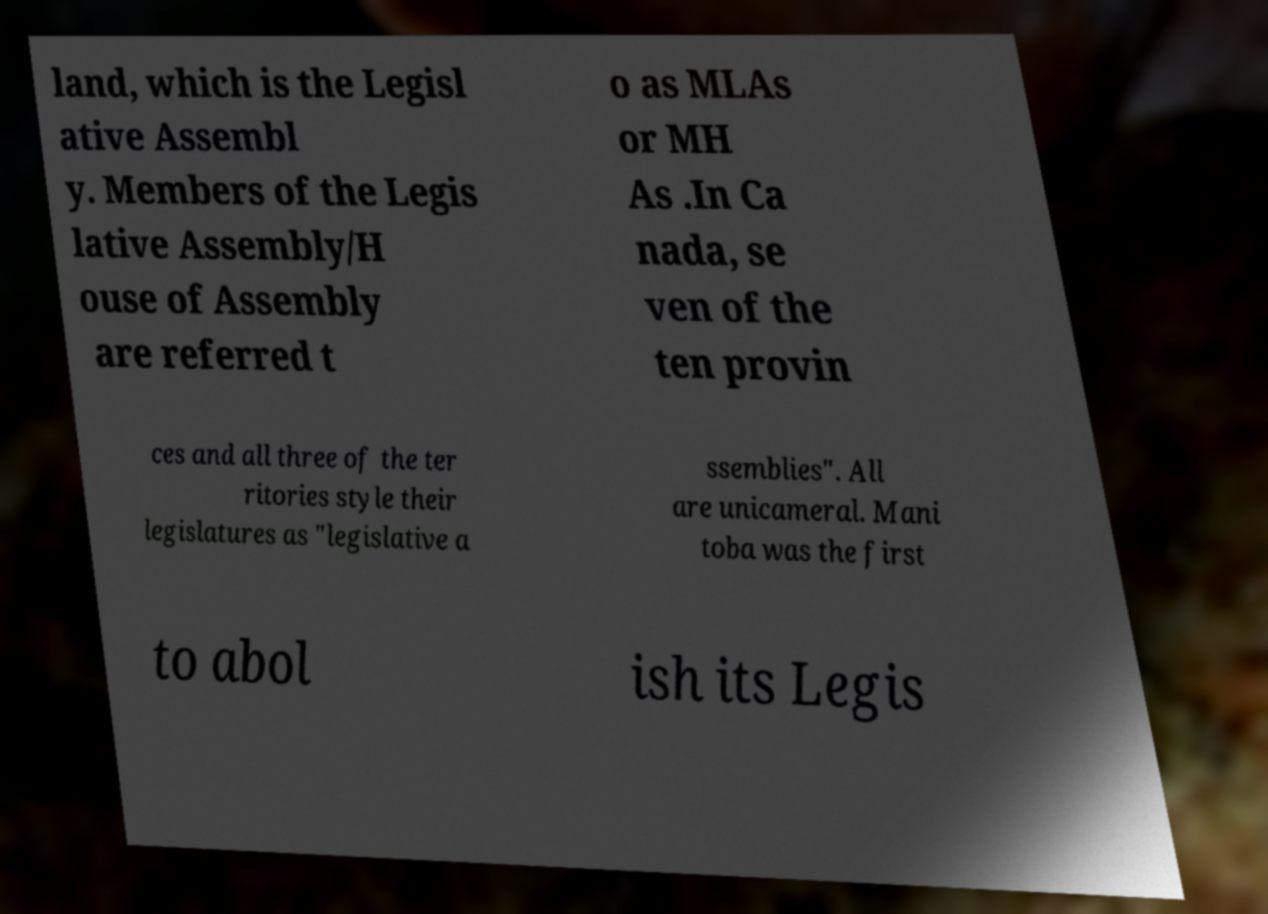There's text embedded in this image that I need extracted. Can you transcribe it verbatim? land, which is the Legisl ative Assembl y. Members of the Legis lative Assembly/H ouse of Assembly are referred t o as MLAs or MH As .In Ca nada, se ven of the ten provin ces and all three of the ter ritories style their legislatures as "legislative a ssemblies". All are unicameral. Mani toba was the first to abol ish its Legis 